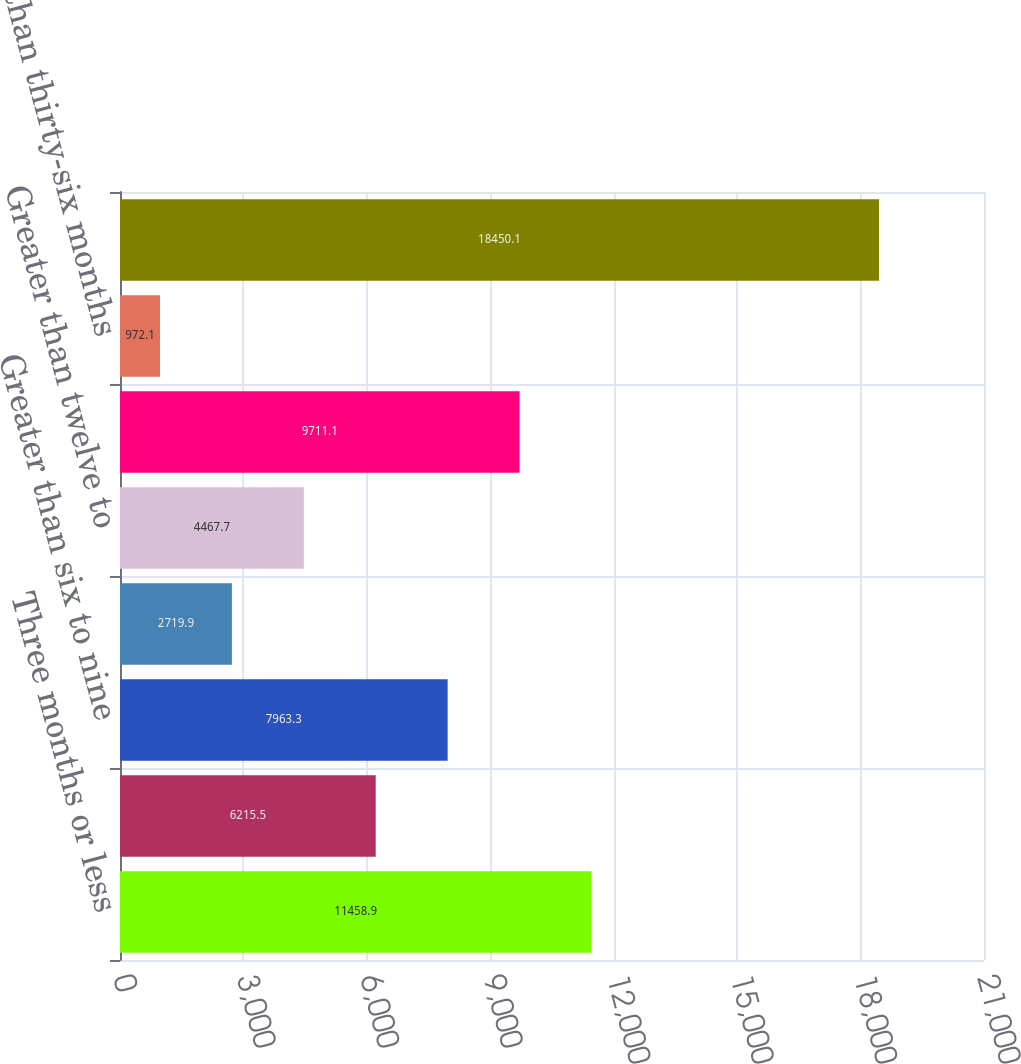<chart> <loc_0><loc_0><loc_500><loc_500><bar_chart><fcel>Three months or less<fcel>Greater than three to six<fcel>Greater than six to nine<fcel>Greater than nine to twelve<fcel>Greater than twelve to<fcel>Greater than twenty-four to<fcel>Greater than thirty-six months<fcel>Total fixed maturity<nl><fcel>11458.9<fcel>6215.5<fcel>7963.3<fcel>2719.9<fcel>4467.7<fcel>9711.1<fcel>972.1<fcel>18450.1<nl></chart> 